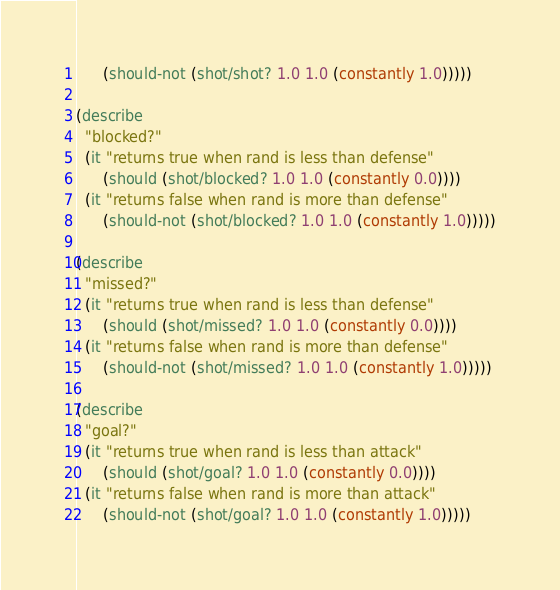Convert code to text. <code><loc_0><loc_0><loc_500><loc_500><_Clojure_>      (should-not (shot/shot? 1.0 1.0 (constantly 1.0)))))

(describe
  "blocked?"
  (it "returns true when rand is less than defense"
      (should (shot/blocked? 1.0 1.0 (constantly 0.0))))
  (it "returns false when rand is more than defense"
      (should-not (shot/blocked? 1.0 1.0 (constantly 1.0)))))

(describe
  "missed?"
  (it "returns true when rand is less than defense"
      (should (shot/missed? 1.0 1.0 (constantly 0.0))))
  (it "returns false when rand is more than defense"
      (should-not (shot/missed? 1.0 1.0 (constantly 1.0)))))

(describe
  "goal?"
  (it "returns true when rand is less than attack"
      (should (shot/goal? 1.0 1.0 (constantly 0.0))))
  (it "returns false when rand is more than attack"
      (should-not (shot/goal? 1.0 1.0 (constantly 1.0)))))

</code> 